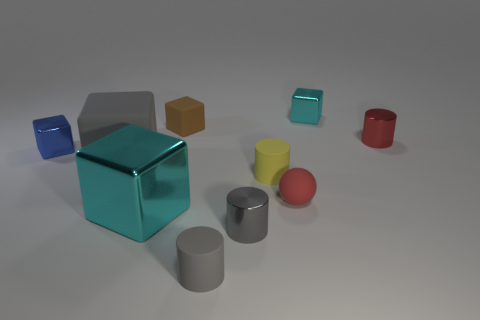What time of day does the lighting suggest in this scene? The lighting in this scene is soft and diffused, lacking any hard shadows or indications of direct sunlight. This could suggest an indoor setting with artificial lighting, rather than a time of day. It's likely that the light source is not visible and produces a neutral-white light that evenly illuminates the scene. 